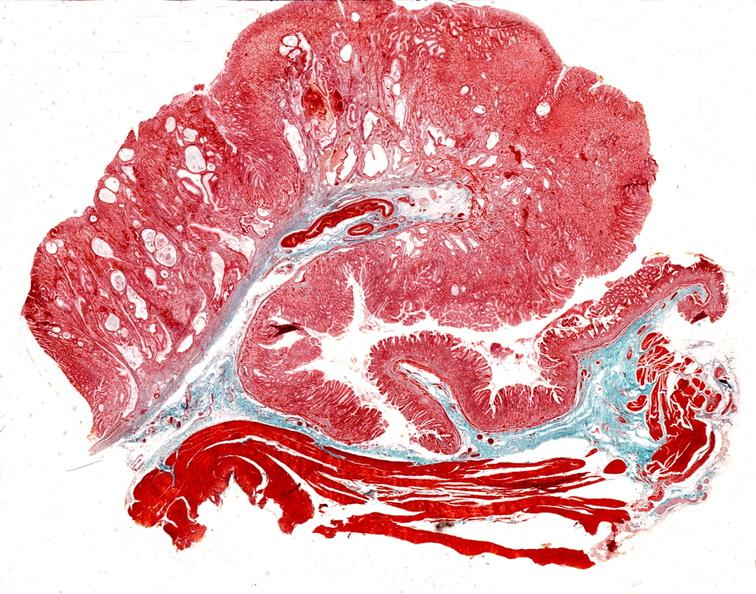s mixed mesodermal tumor present?
Answer the question using a single word or phrase. No 